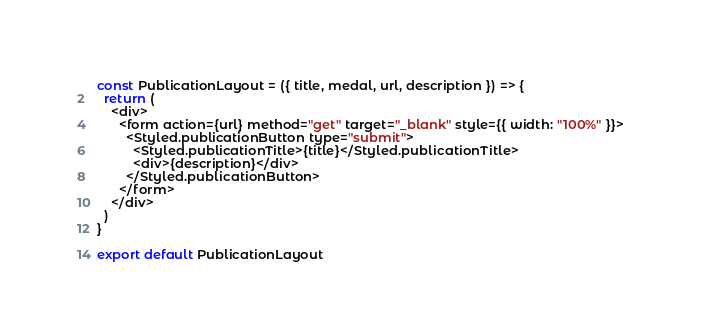<code> <loc_0><loc_0><loc_500><loc_500><_JavaScript_>
const PublicationLayout = ({ title, medal, url, description }) => {
  return (
    <div>
      <form action={url} method="get" target="_blank" style={{ width: "100%" }}>
        <Styled.publicationButton type="submit">
          <Styled.publicationTitle>{title}</Styled.publicationTitle>
          <div>{description}</div>
        </Styled.publicationButton>
      </form>
    </div>
  )
}

export default PublicationLayout
</code> 